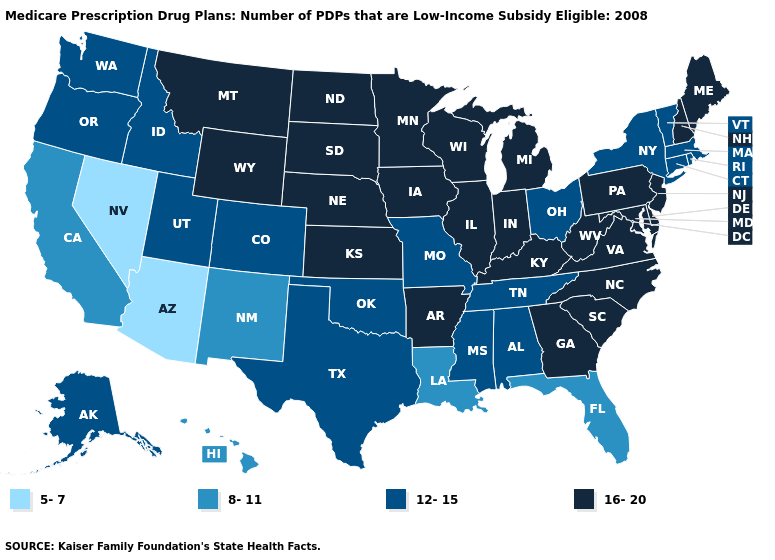Which states hav the highest value in the MidWest?
Answer briefly. Iowa, Illinois, Indiana, Kansas, Michigan, Minnesota, North Dakota, Nebraska, South Dakota, Wisconsin. Which states hav the highest value in the South?
Be succinct. Arkansas, Delaware, Georgia, Kentucky, Maryland, North Carolina, South Carolina, Virginia, West Virginia. Which states have the lowest value in the USA?
Be succinct. Arizona, Nevada. Name the states that have a value in the range 5-7?
Answer briefly. Arizona, Nevada. Is the legend a continuous bar?
Keep it brief. No. Name the states that have a value in the range 5-7?
Short answer required. Arizona, Nevada. Does Virginia have the lowest value in the USA?
Give a very brief answer. No. What is the value of Missouri?
Give a very brief answer. 12-15. Among the states that border Florida , which have the lowest value?
Quick response, please. Alabama. How many symbols are there in the legend?
Concise answer only. 4. Name the states that have a value in the range 5-7?
Be succinct. Arizona, Nevada. Does Wisconsin have a higher value than Connecticut?
Give a very brief answer. Yes. Name the states that have a value in the range 12-15?
Answer briefly. Alaska, Alabama, Colorado, Connecticut, Idaho, Massachusetts, Missouri, Mississippi, New York, Ohio, Oklahoma, Oregon, Rhode Island, Tennessee, Texas, Utah, Vermont, Washington. What is the value of Delaware?
Concise answer only. 16-20. 